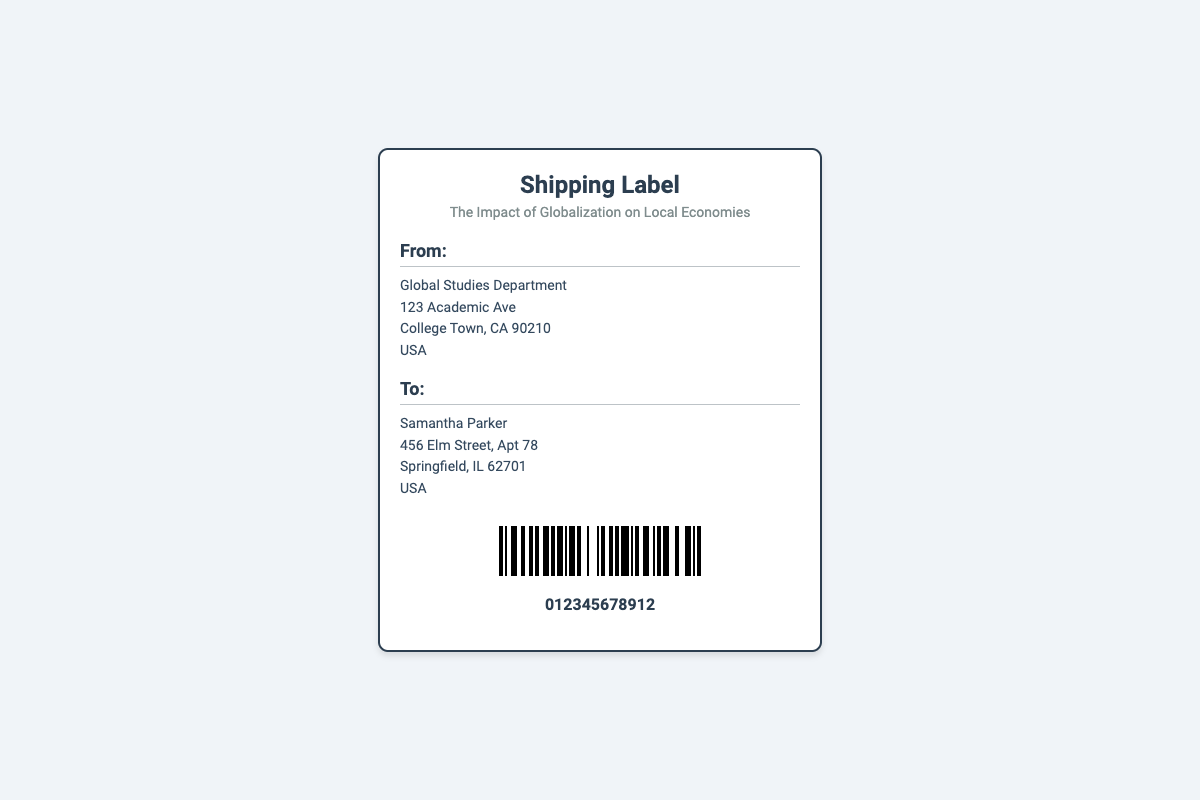What is the title of the document? The title of the document is presented prominently in the header of the shipping label.
Answer: The Impact of Globalization on Local Economies Who is the sender? The sender's details are located in the "From" section of the shipping label.
Answer: Global Studies Department What is the address of the recipient? The recipient's address is stated in the "To" section.
Answer: 456 Elm Street, Apt 78, Springfield, IL 62701, USA What is the barcode number? The barcode number is specifically mentioned below the barcode graphic.
Answer: 012345678912 What is the state of the recipient? The state is part of the recipient's address, indicating the location within the United States.
Answer: Illinois How many lines are in the sender's address? The sender's address consists of multiple lines indicating the detailed location within the document layout.
Answer: 4 lines What type of document is this? The document type can be inferred from the title and overall layout designed for shipping purposes.
Answer: Shipping Label What information is indicated under "To"? The "To" section provides details specific to the recipient, marking the destination for the package.
Answer: Samantha Parker What is the subtitle of the document? The subtitle is outlined immediately below the main title, providing additional context about the document's focus.
Answer: The Impact of Globalization on Local Economies 